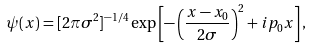Convert formula to latex. <formula><loc_0><loc_0><loc_500><loc_500>\psi ( x ) = [ 2 \pi \sigma ^ { 2 } ] ^ { - 1 / 4 } \exp \left [ - \left ( \frac { x - x _ { 0 } } { 2 \sigma } \right ) ^ { 2 } + i p _ { 0 } x \right ] ,</formula> 